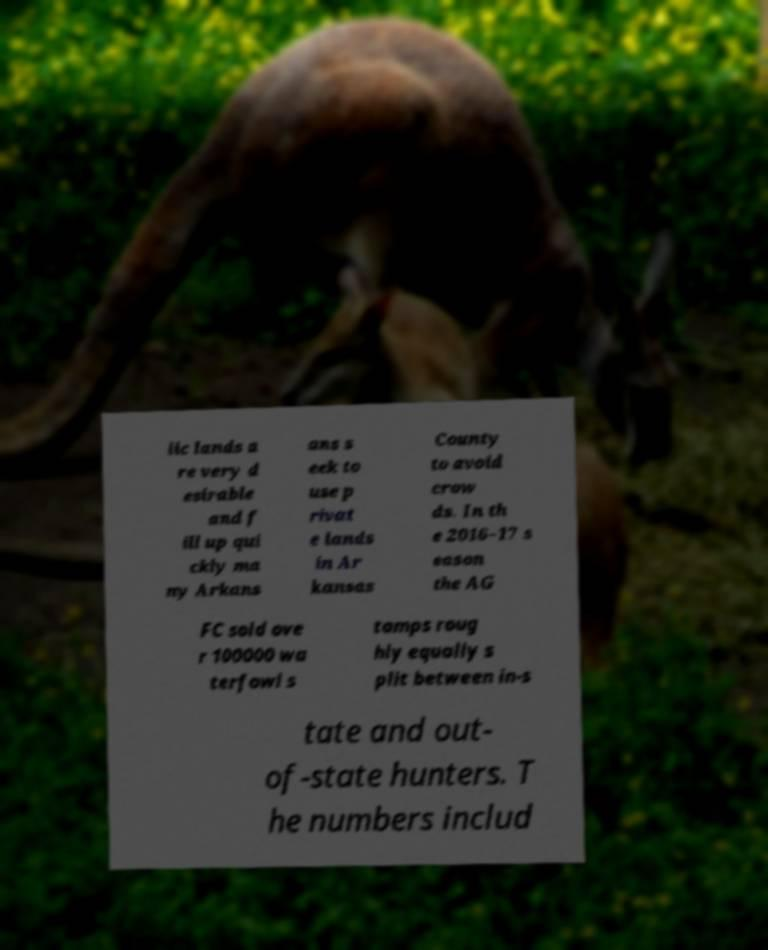Could you extract and type out the text from this image? lic lands a re very d esirable and f ill up qui ckly ma ny Arkans ans s eek to use p rivat e lands in Ar kansas County to avoid crow ds. In th e 2016–17 s eason the AG FC sold ove r 100000 wa terfowl s tamps roug hly equally s plit between in-s tate and out- of-state hunters. T he numbers includ 